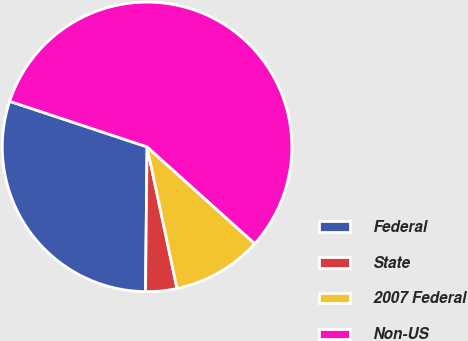<chart> <loc_0><loc_0><loc_500><loc_500><pie_chart><fcel>Federal<fcel>State<fcel>2007 Federal<fcel>Non-US<nl><fcel>29.93%<fcel>3.49%<fcel>10.03%<fcel>56.56%<nl></chart> 